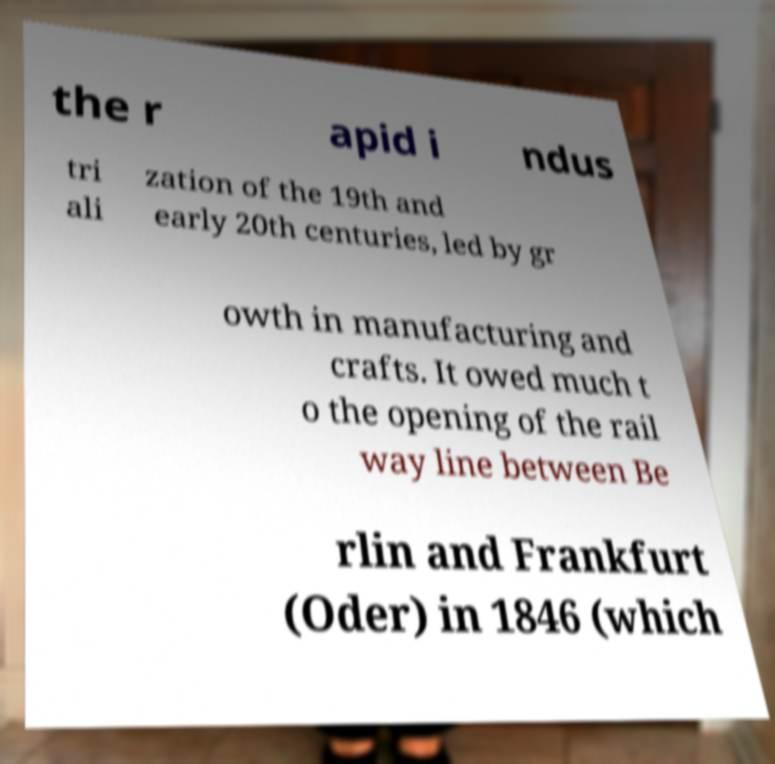Could you extract and type out the text from this image? the r apid i ndus tri ali zation of the 19th and early 20th centuries, led by gr owth in manufacturing and crafts. It owed much t o the opening of the rail way line between Be rlin and Frankfurt (Oder) in 1846 (which 